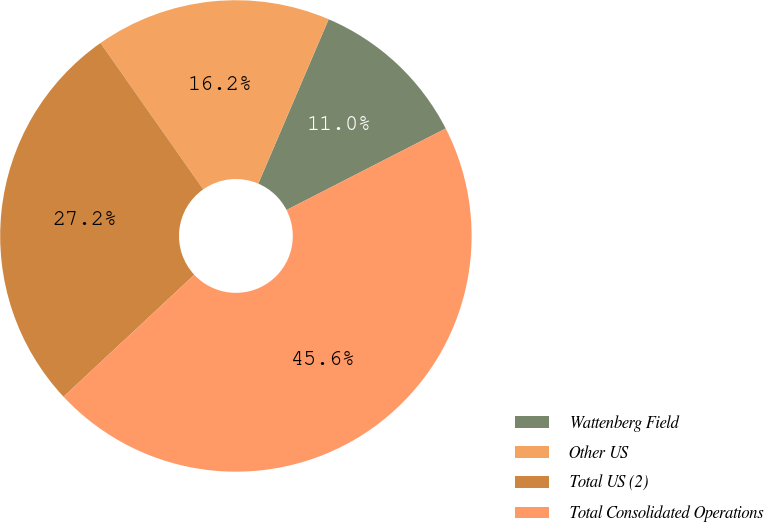Convert chart. <chart><loc_0><loc_0><loc_500><loc_500><pie_chart><fcel>Wattenberg Field<fcel>Other US<fcel>Total US (2)<fcel>Total Consolidated Operations<nl><fcel>11.03%<fcel>16.18%<fcel>27.21%<fcel>45.59%<nl></chart> 